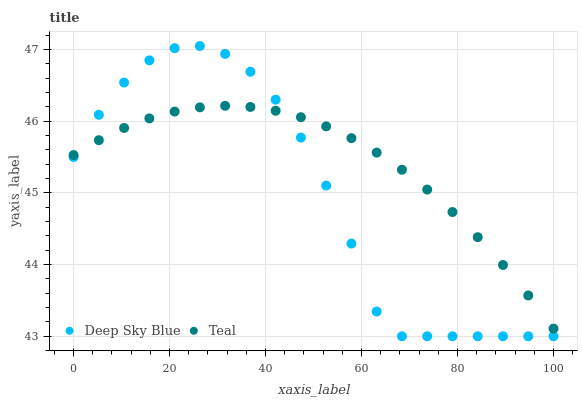Does Deep Sky Blue have the minimum area under the curve?
Answer yes or no. Yes. Does Teal have the maximum area under the curve?
Answer yes or no. Yes. Does Deep Sky Blue have the maximum area under the curve?
Answer yes or no. No. Is Teal the smoothest?
Answer yes or no. Yes. Is Deep Sky Blue the roughest?
Answer yes or no. Yes. Is Deep Sky Blue the smoothest?
Answer yes or no. No. Does Deep Sky Blue have the lowest value?
Answer yes or no. Yes. Does Deep Sky Blue have the highest value?
Answer yes or no. Yes. Does Teal intersect Deep Sky Blue?
Answer yes or no. Yes. Is Teal less than Deep Sky Blue?
Answer yes or no. No. Is Teal greater than Deep Sky Blue?
Answer yes or no. No. 